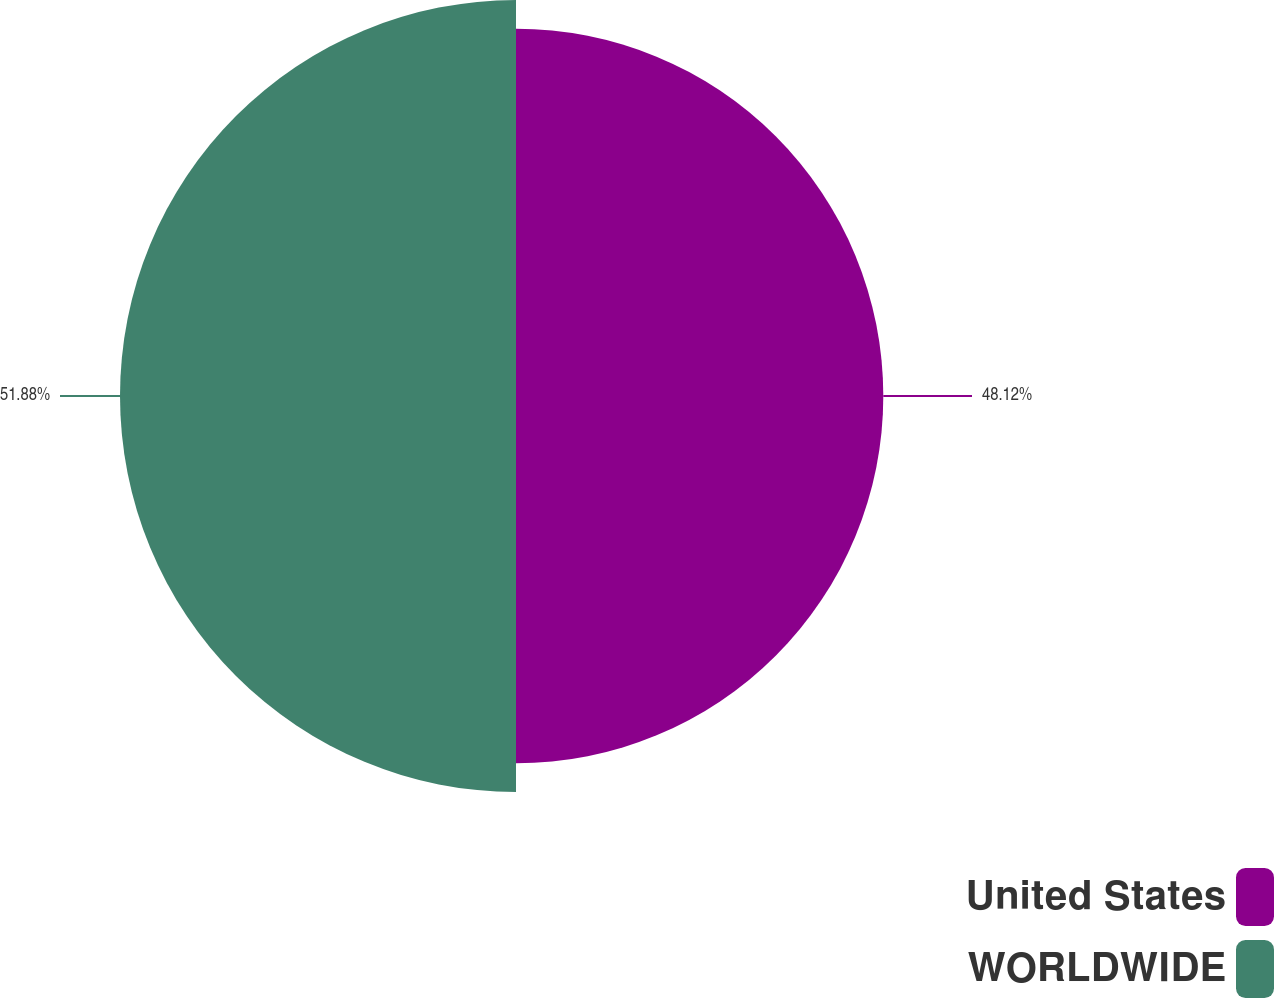Convert chart. <chart><loc_0><loc_0><loc_500><loc_500><pie_chart><fcel>United States<fcel>WORLDWIDE<nl><fcel>48.12%<fcel>51.88%<nl></chart> 